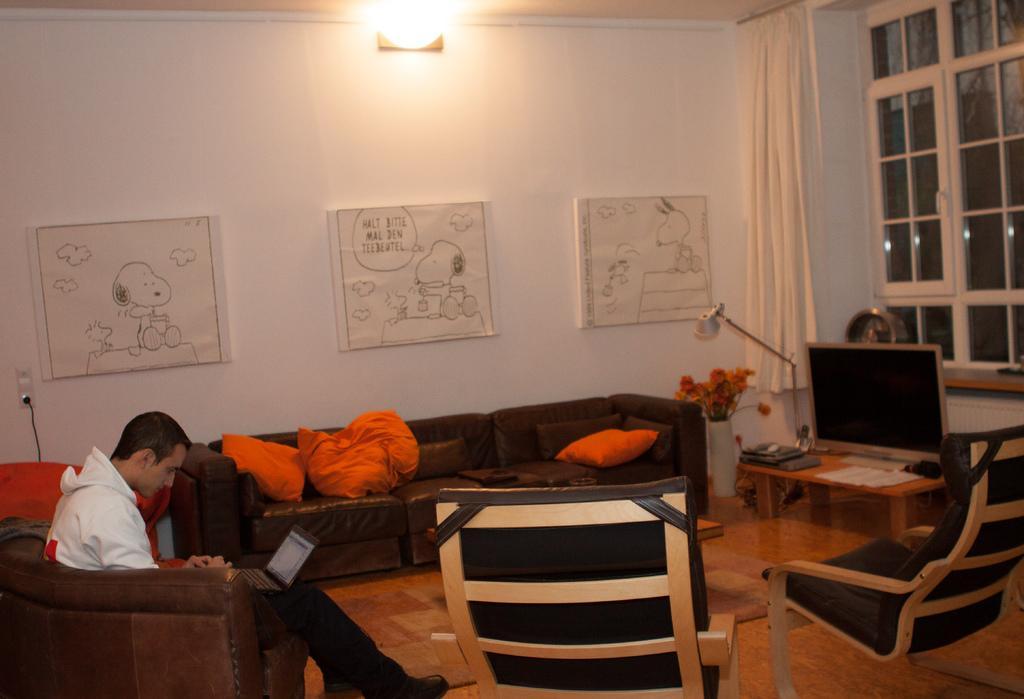Can you describe this image briefly? This picture is taken in a room. The room is filled with sofas and chairs. Towards the left corner there is a man sitting on the sofa, he is wearing a white jacket and working on laptop. In the center there is a sofa, on the sofa there are three pillows. Towards the right corner there is a table, on the table there is a television. In the background there is a wall and some charts stick to it. In the top right there is a window and a curtain. 